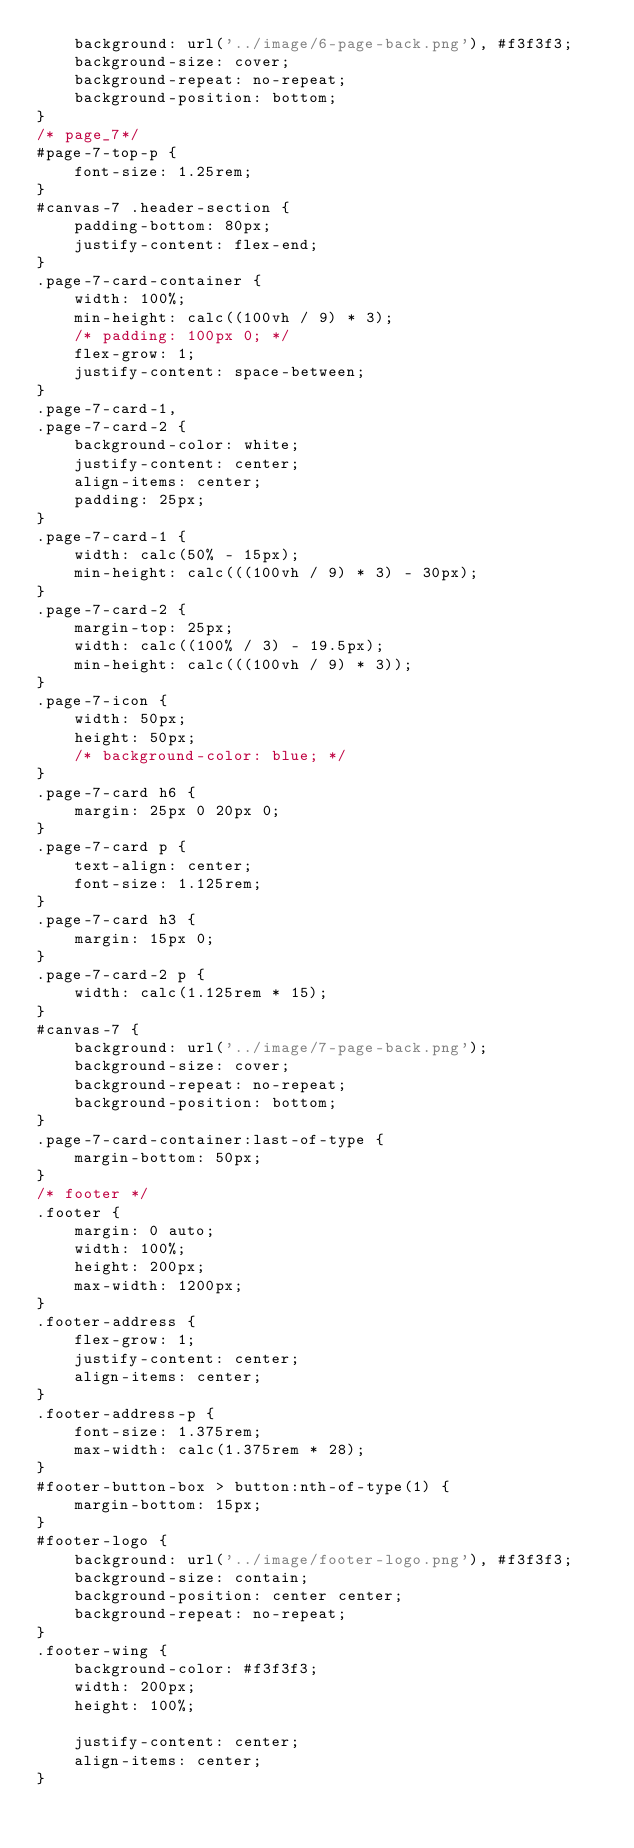<code> <loc_0><loc_0><loc_500><loc_500><_CSS_>    background: url('../image/6-page-back.png'), #f3f3f3;
    background-size: cover;
    background-repeat: no-repeat;
    background-position: bottom;
}
/* page_7*/
#page-7-top-p {
    font-size: 1.25rem;
}
#canvas-7 .header-section {
    padding-bottom: 80px;
    justify-content: flex-end;
}
.page-7-card-container {
    width: 100%;
    min-height: calc((100vh / 9) * 3);
    /* padding: 100px 0; */
    flex-grow: 1;
    justify-content: space-between;
}
.page-7-card-1,
.page-7-card-2 {
    background-color: white;
    justify-content: center;
    align-items: center;
    padding: 25px;
}
.page-7-card-1 {
    width: calc(50% - 15px);
    min-height: calc(((100vh / 9) * 3) - 30px);
}
.page-7-card-2 {
    margin-top: 25px;
    width: calc((100% / 3) - 19.5px);
    min-height: calc(((100vh / 9) * 3));
}
.page-7-icon {
    width: 50px;
    height: 50px;
    /* background-color: blue; */
}
.page-7-card h6 {
    margin: 25px 0 20px 0;
}
.page-7-card p {
    text-align: center;
    font-size: 1.125rem;
}
.page-7-card h3 {
    margin: 15px 0;
}
.page-7-card-2 p {
    width: calc(1.125rem * 15);
}
#canvas-7 {
    background: url('../image/7-page-back.png');
    background-size: cover;
    background-repeat: no-repeat;
    background-position: bottom;
}
.page-7-card-container:last-of-type {
    margin-bottom: 50px;
}
/* footer */
.footer {
    margin: 0 auto;
    width: 100%;
    height: 200px;
    max-width: 1200px;
}
.footer-address {
    flex-grow: 1;
    justify-content: center;
    align-items: center;
}
.footer-address-p {
    font-size: 1.375rem;
    max-width: calc(1.375rem * 28);
}
#footer-button-box > button:nth-of-type(1) {
    margin-bottom: 15px;
}
#footer-logo {
    background: url('../image/footer-logo.png'), #f3f3f3;
    background-size: contain;
    background-position: center center;
    background-repeat: no-repeat;
}
.footer-wing {
    background-color: #f3f3f3;
    width: 200px;
    height: 100%;

    justify-content: center;
    align-items: center;
}
</code> 